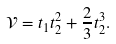Convert formula to latex. <formula><loc_0><loc_0><loc_500><loc_500>\mathcal { V } = t _ { 1 } t _ { 2 } ^ { 2 } + \frac { 2 } { 3 } t _ { 2 } ^ { 3 } .</formula> 